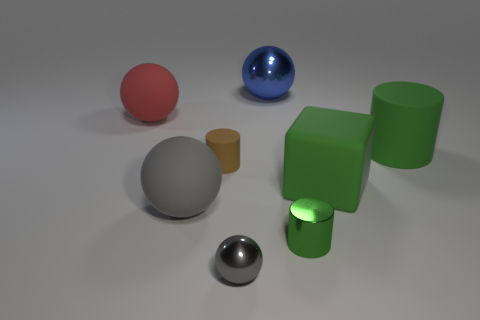Subtract all big spheres. How many spheres are left? 1 Add 1 balls. How many objects exist? 9 Subtract all brown cylinders. How many cylinders are left? 2 Subtract 1 cubes. How many cubes are left? 0 Add 3 large blue spheres. How many large blue spheres are left? 4 Add 7 large red cylinders. How many large red cylinders exist? 7 Subtract 0 red cylinders. How many objects are left? 8 Subtract all cylinders. How many objects are left? 5 Subtract all brown cylinders. Subtract all red blocks. How many cylinders are left? 2 Subtract all gray spheres. How many green cylinders are left? 2 